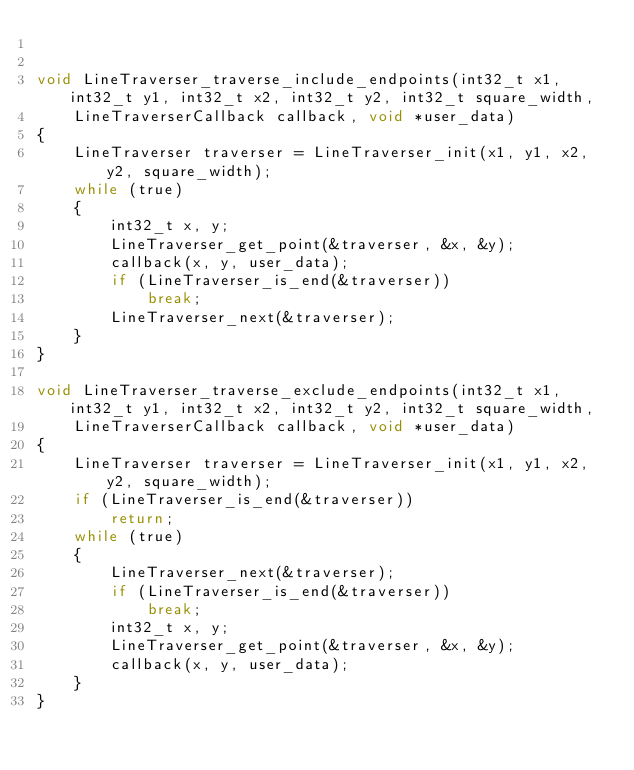<code> <loc_0><loc_0><loc_500><loc_500><_C_>

void LineTraverser_traverse_include_endpoints(int32_t x1, int32_t y1, int32_t x2, int32_t y2, int32_t square_width, 
    LineTraverserCallback callback, void *user_data)
{
    LineTraverser traverser = LineTraverser_init(x1, y1, x2, y2, square_width);
    while (true)
    {
        int32_t x, y;
        LineTraverser_get_point(&traverser, &x, &y);
        callback(x, y, user_data);
        if (LineTraverser_is_end(&traverser))
            break;
        LineTraverser_next(&traverser);
    }
}

void LineTraverser_traverse_exclude_endpoints(int32_t x1, int32_t y1, int32_t x2, int32_t y2, int32_t square_width, 
    LineTraverserCallback callback, void *user_data)
{
    LineTraverser traverser = LineTraverser_init(x1, y1, x2, y2, square_width);
    if (LineTraverser_is_end(&traverser))
        return;
    while (true)
    {
        LineTraverser_next(&traverser);
        if (LineTraverser_is_end(&traverser))
            break;
        int32_t x, y;
        LineTraverser_get_point(&traverser, &x, &y);
        callback(x, y, user_data);
    }
}
</code> 